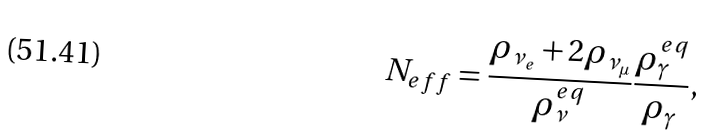Convert formula to latex. <formula><loc_0><loc_0><loc_500><loc_500>N _ { e f f } = \frac { \rho _ { \nu _ { e } } + 2 \rho _ { \nu _ { \mu } } } { \rho _ { \nu } ^ { e q } } \frac { \rho _ { \gamma } ^ { e q } } { \rho _ { \gamma } } ,</formula> 